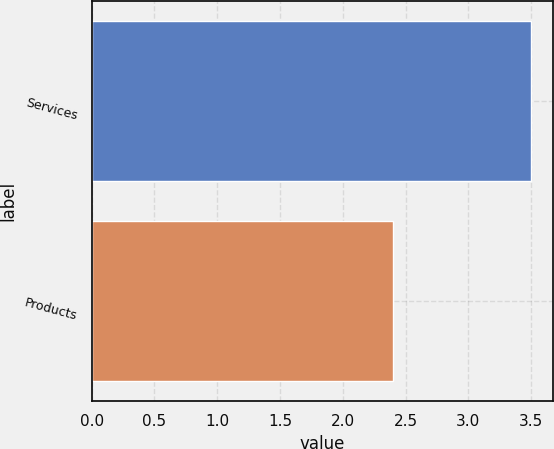Convert chart to OTSL. <chart><loc_0><loc_0><loc_500><loc_500><bar_chart><fcel>Services<fcel>Products<nl><fcel>3.5<fcel>2.4<nl></chart> 